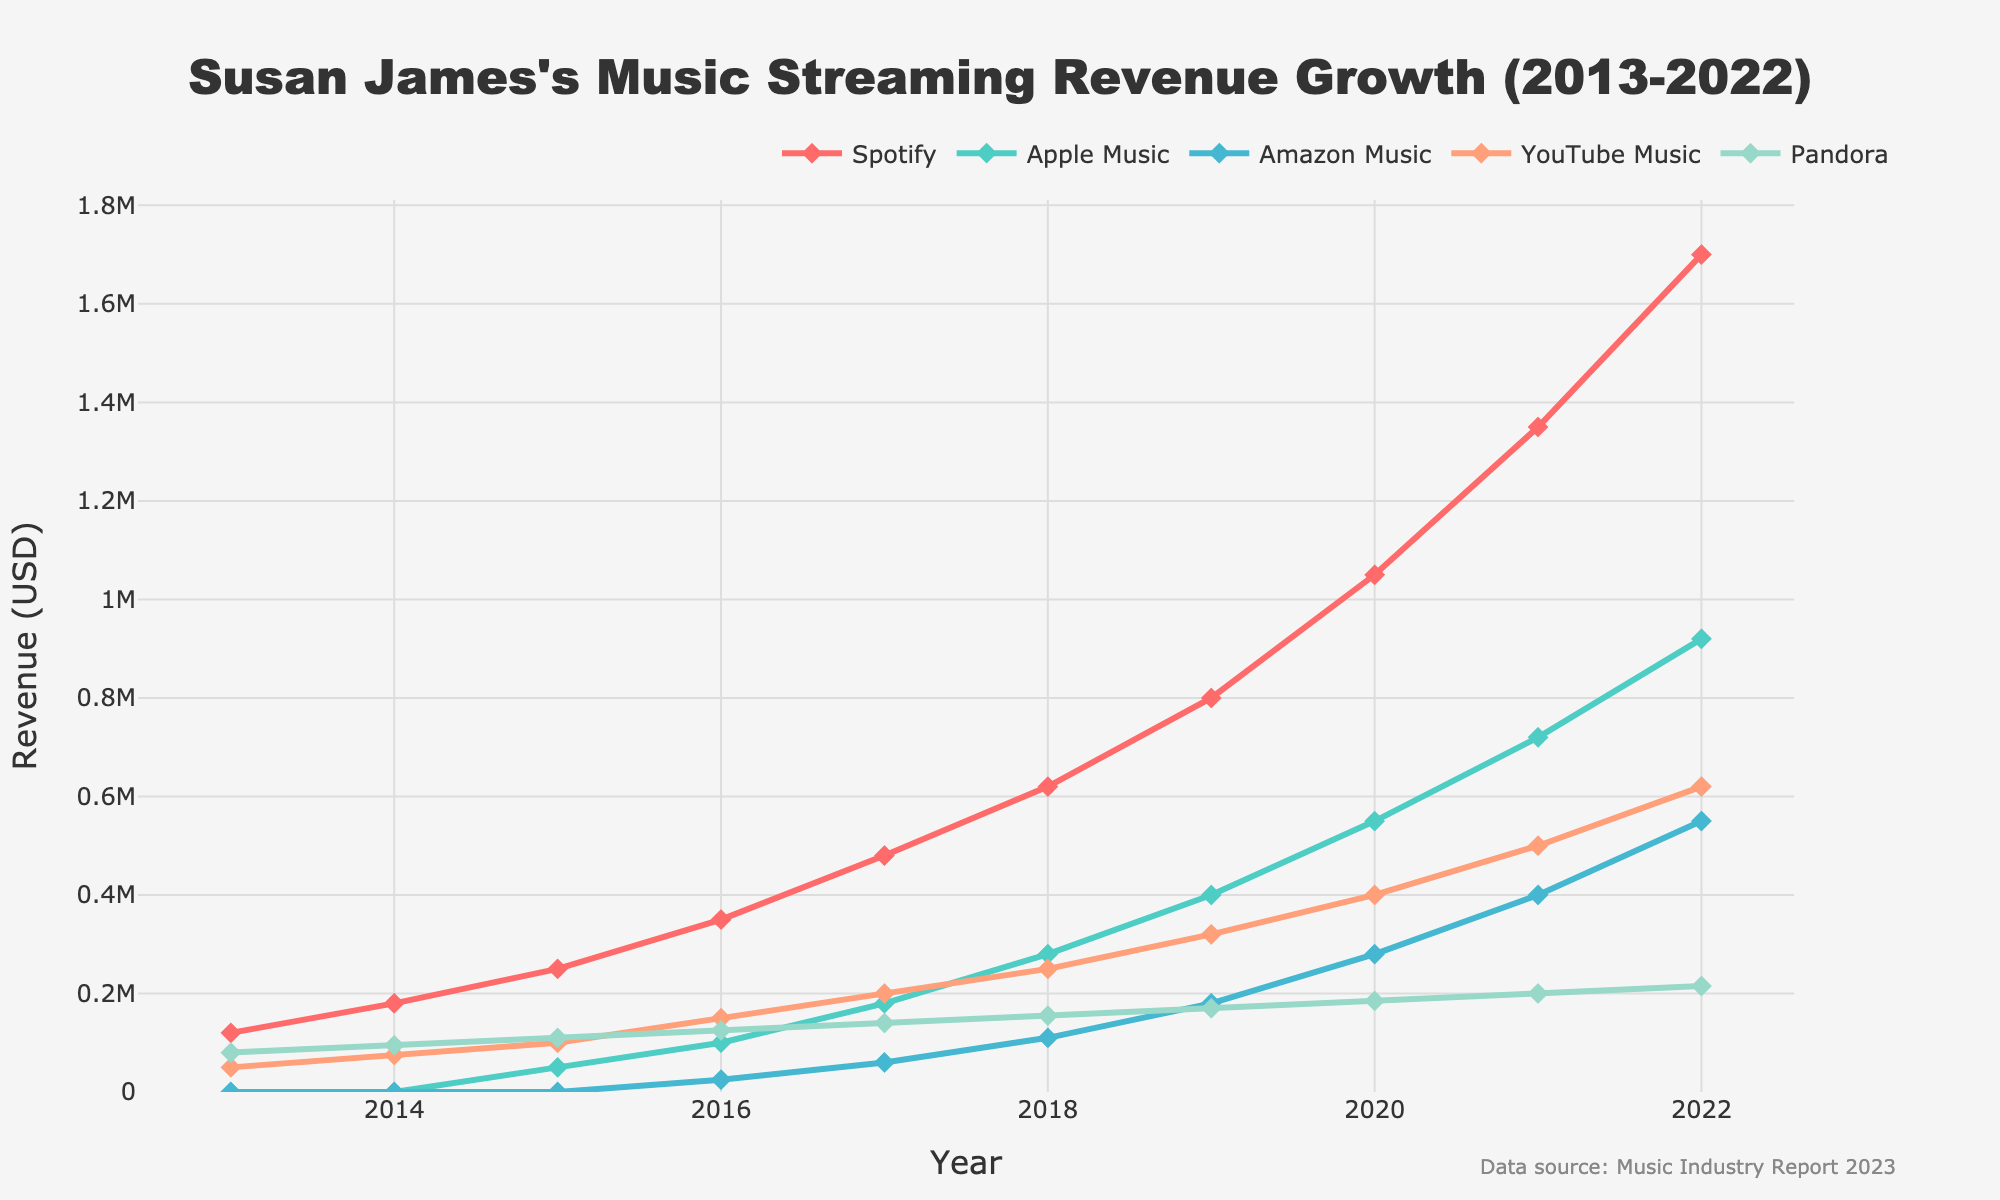What's the highest revenue achieved on Spotify throughout the years? Look for the highest value on the line representing Spotify. From the chart, the highest revenue for Spotify is in 2022.
Answer: 1,700,000 How much did Susan James's revenue from Apple Music grow from 2015 to 2022? Find the revenue for Apple Music in 2015 and 2022, then compute the difference: 920,000 (2022) - 50,000 (2015).
Answer: 870,000 In which year did Pandora revenue stop showing the highest value compared to other platforms? Look for a year where Pandora's revenue was initially the highest but then fell behind at least one other platform. The year Susan James's Pandora revenue fell behind Spotify was in 2015.
Answer: 2015 What was the total revenue from all platforms in 2020? Add revenue from all platforms for the year 2020: 1,050,000 (Spotify) + 550,000 (Apple Music) + 280,000 (Amazon Music) + 400,000 (YouTube Music) + 185,000 (Pandora).
Answer: 2,465,000 Which platform had the steepest revenue increase between 2016 and 2017? Compare the revenue increments for all platforms between 2016 and 2017. The biggest jump is observed for Spotify: 480,000 - 350,000 = 130,000.
Answer: Spotify In what year did YouTube Music reach half of Pandora’s revenue for that year? Compare YouTube Music revenue to half of Pandora's revenue each year, checking when they are equal. In 2015, YouTube Music’s 100,000 is very close to half of Pandora's 110,000.
Answer: 2015 How much did Susan James’s total revenue grow on Spotify and Amazon Music combined between 2016 and 2022? Compute the total revenue in 2016 for Spotify and Amazon Music combined and compare it to the total in 2022: (1,700,000 + 550,000) - (350,000 + 25,000).
Answer: 1,875,000 Which platform showed the most consistent growth over the decade? Observing the slopes and steady increments on the chart, Apple Music displays the most consistent year-over-year growth.
Answer: Apple Music Between 2013 and 2018, which platform saw the least increase in revenue? Compare the increases from 2013 to 2018, look at the smallest difference: Pandora’s increase from 80,000 to 155,000 is the smallest change.
Answer: Pandora In 2019, how did Apple Music’s revenue compare to YouTube Music’s revenue? Refer to 2019 revenue values, compare Apple Music (400,000) to YouTube Music (320,000). Apple Music's revenue was higher.
Answer: Apple Music's was higher by 80,000 